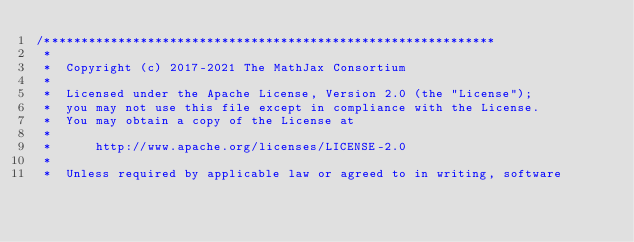<code> <loc_0><loc_0><loc_500><loc_500><_TypeScript_>/*************************************************************
 *
 *  Copyright (c) 2017-2021 The MathJax Consortium
 *
 *  Licensed under the Apache License, Version 2.0 (the "License");
 *  you may not use this file except in compliance with the License.
 *  You may obtain a copy of the License at
 *
 *      http://www.apache.org/licenses/LICENSE-2.0
 *
 *  Unless required by applicable law or agreed to in writing, software</code> 